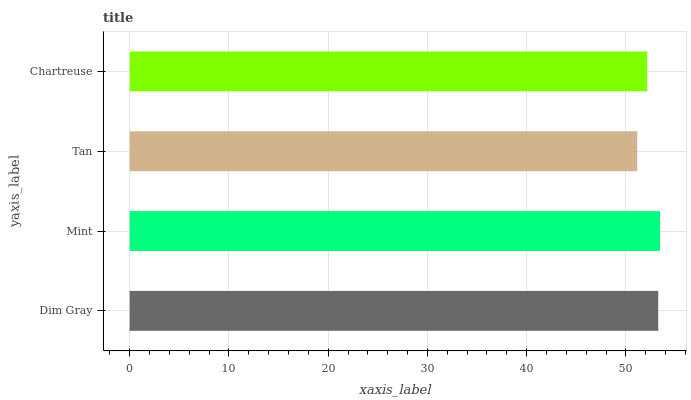Is Tan the minimum?
Answer yes or no. Yes. Is Mint the maximum?
Answer yes or no. Yes. Is Mint the minimum?
Answer yes or no. No. Is Tan the maximum?
Answer yes or no. No. Is Mint greater than Tan?
Answer yes or no. Yes. Is Tan less than Mint?
Answer yes or no. Yes. Is Tan greater than Mint?
Answer yes or no. No. Is Mint less than Tan?
Answer yes or no. No. Is Dim Gray the high median?
Answer yes or no. Yes. Is Chartreuse the low median?
Answer yes or no. Yes. Is Mint the high median?
Answer yes or no. No. Is Mint the low median?
Answer yes or no. No. 